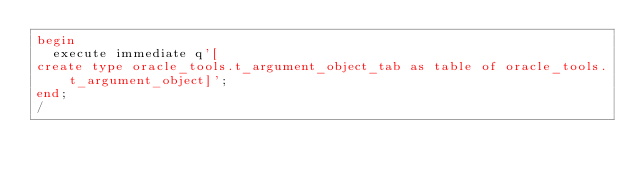<code> <loc_0><loc_0><loc_500><loc_500><_SQL_>begin
  execute immediate q'[
create type oracle_tools.t_argument_object_tab as table of oracle_tools.t_argument_object]';
end;
/
</code> 